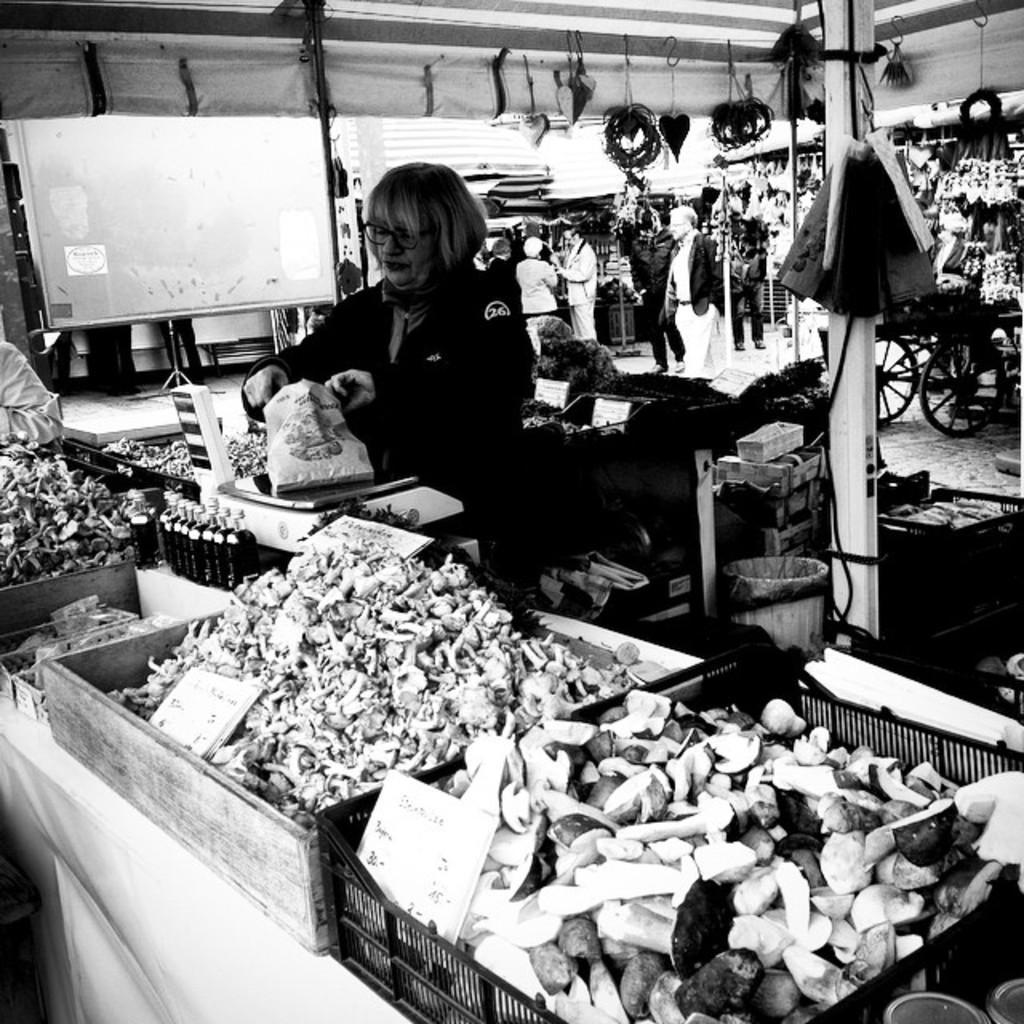How would you summarize this image in a sentence or two? This is a black and white image in this image there are trays, in that trays there is food item, and there are people under the tent. 